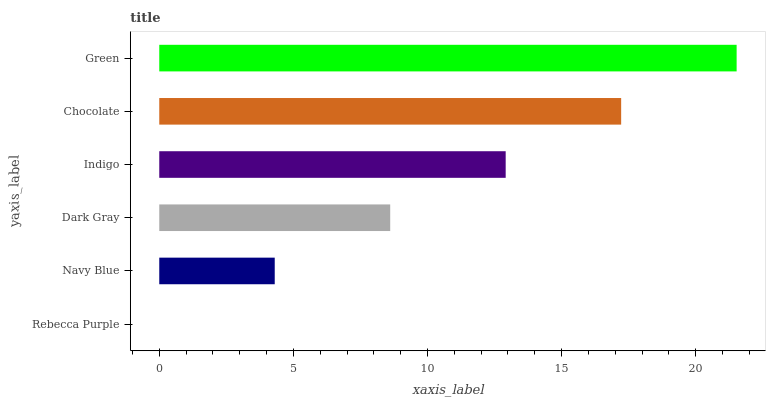Is Rebecca Purple the minimum?
Answer yes or no. Yes. Is Green the maximum?
Answer yes or no. Yes. Is Navy Blue the minimum?
Answer yes or no. No. Is Navy Blue the maximum?
Answer yes or no. No. Is Navy Blue greater than Rebecca Purple?
Answer yes or no. Yes. Is Rebecca Purple less than Navy Blue?
Answer yes or no. Yes. Is Rebecca Purple greater than Navy Blue?
Answer yes or no. No. Is Navy Blue less than Rebecca Purple?
Answer yes or no. No. Is Indigo the high median?
Answer yes or no. Yes. Is Dark Gray the low median?
Answer yes or no. Yes. Is Rebecca Purple the high median?
Answer yes or no. No. Is Rebecca Purple the low median?
Answer yes or no. No. 